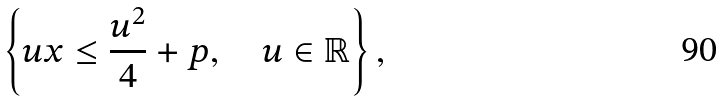Convert formula to latex. <formula><loc_0><loc_0><loc_500><loc_500>\left \{ u x \leq \frac { u ^ { 2 } } { 4 } + p , \quad u \in \mathbb { R } \right \} ,</formula> 